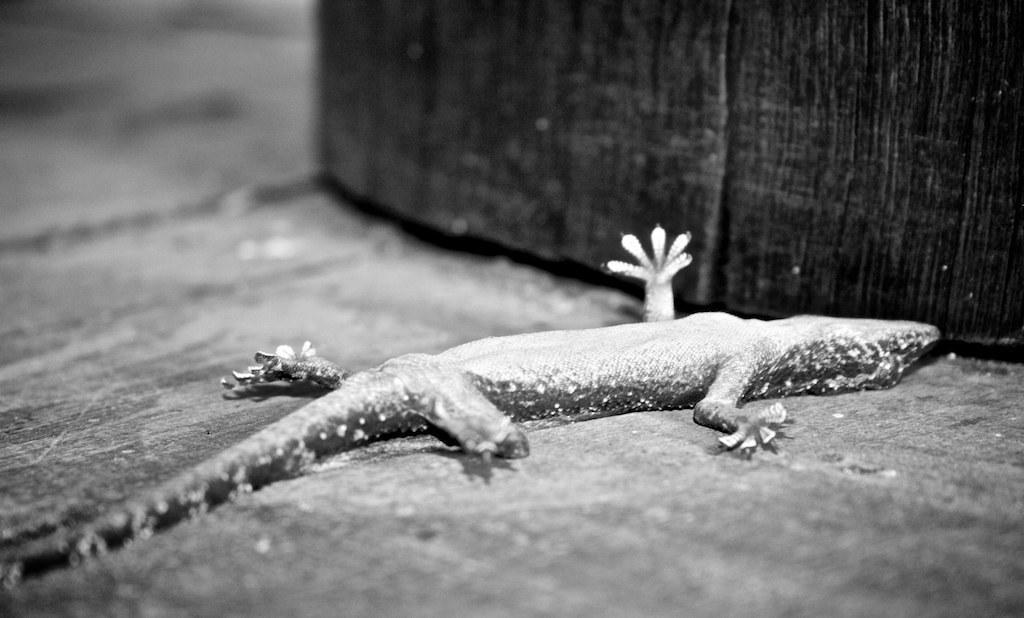What is the main subject in the center of the image? There is a lizard in the center of the image. What type of surface is visible at the bottom of the image? There is a floor visible at the bottom of the image. What object can be seen at the top of the image? There is a wooden board-like object at the top of the image. How would you describe the background of the image? The background of the image is blurry. What type of battle is taking place between the lizard and the horse in the image? There is no horse present in the image, and the lizard is not engaged in any battle. 